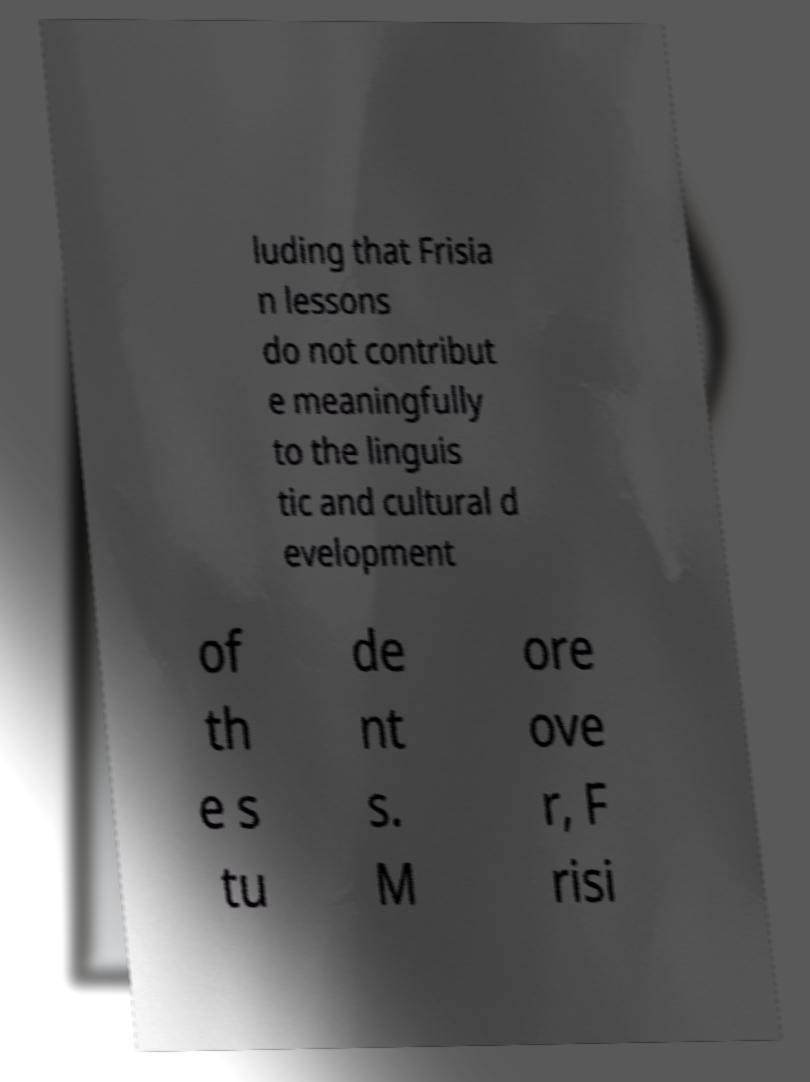There's text embedded in this image that I need extracted. Can you transcribe it verbatim? luding that Frisia n lessons do not contribut e meaningfully to the linguis tic and cultural d evelopment of th e s tu de nt s. M ore ove r, F risi 